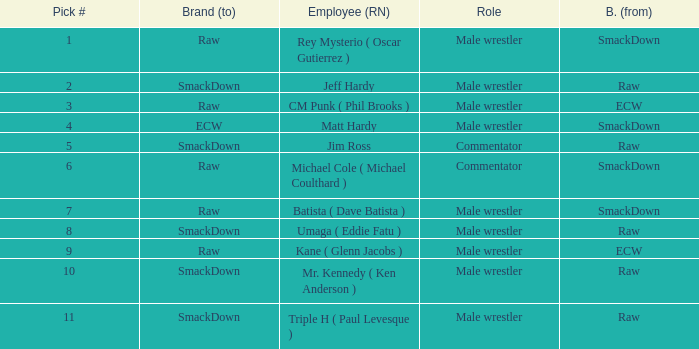What is the true name of the male wrestler from raw with a draft choice lower than 6? Jeff Hardy. 